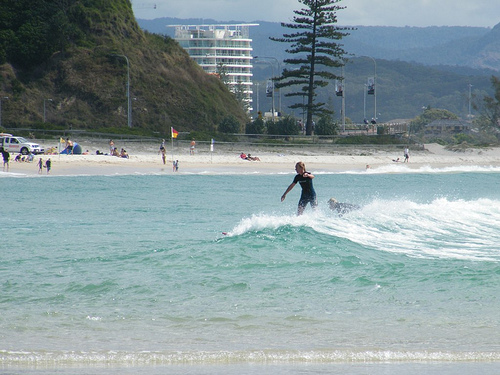Please provide a short description for this region: [0.34, 0.17, 0.51, 0.26]. The specified region [0.34, 0.17, 0.51, 0.26] of the image captures a building nestled behind a hill, contributing to the scenic backdrop of the shoreline. 